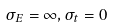<formula> <loc_0><loc_0><loc_500><loc_500>\sigma _ { E } = \infty , \sigma _ { t } = 0</formula> 